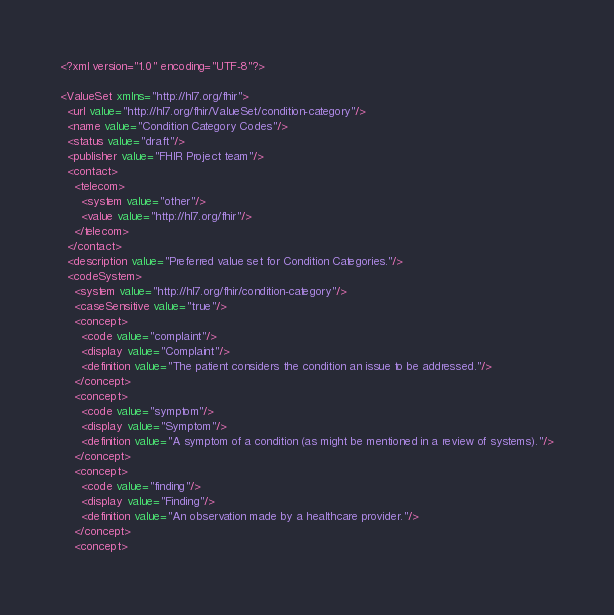<code> <loc_0><loc_0><loc_500><loc_500><_XML_><?xml version="1.0" encoding="UTF-8"?>

<ValueSet xmlns="http://hl7.org/fhir">
  <url value="http://hl7.org/fhir/ValueSet/condition-category"/>
  <name value="Condition Category Codes"/>
  <status value="draft"/>
  <publisher value="FHIR Project team"/>
  <contact>
    <telecom>
      <system value="other"/>
      <value value="http://hl7.org/fhir"/>
    </telecom>
  </contact>
  <description value="Preferred value set for Condition Categories."/>
  <codeSystem>
    <system value="http://hl7.org/fhir/condition-category"/>
    <caseSensitive value="true"/>
    <concept>
      <code value="complaint"/>
      <display value="Complaint"/>
      <definition value="The patient considers the condition an issue to be addressed."/>
    </concept>
    <concept>
      <code value="symptom"/>
      <display value="Symptom"/>
      <definition value="A symptom of a condition (as might be mentioned in a review of systems)."/>
    </concept>
    <concept>
      <code value="finding"/>
      <display value="Finding"/>
      <definition value="An observation made by a healthcare provider."/>
    </concept>
    <concept></code> 